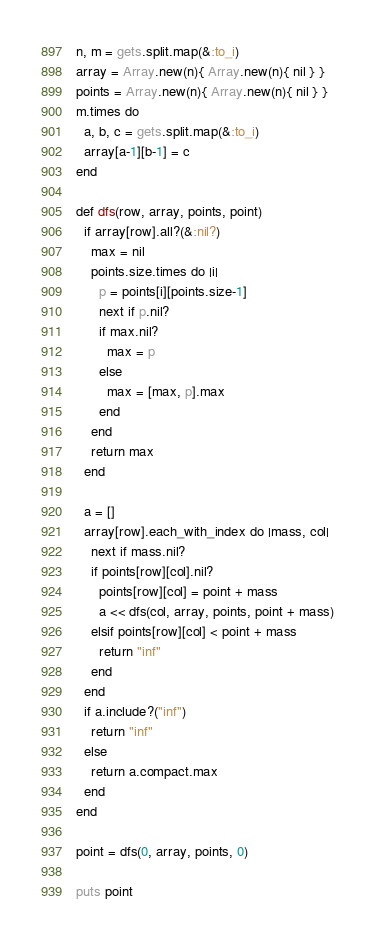Convert code to text. <code><loc_0><loc_0><loc_500><loc_500><_Ruby_>n, m = gets.split.map(&:to_i)
array = Array.new(n){ Array.new(n){ nil } }
points = Array.new(n){ Array.new(n){ nil } }
m.times do
  a, b, c = gets.split.map(&:to_i)
  array[a-1][b-1] = c
end

def dfs(row, array, points, point)
  if array[row].all?(&:nil?)
    max = nil
    points.size.times do |i|
      p = points[i][points.size-1]
      next if p.nil?
      if max.nil?
        max = p
      else
        max = [max, p].max
      end
    end
    return max
  end

  a = []
  array[row].each_with_index do |mass, col|
    next if mass.nil?
    if points[row][col].nil?
      points[row][col] = point + mass
      a << dfs(col, array, points, point + mass)
    elsif points[row][col] < point + mass
      return "inf"
    end
  end
  if a.include?("inf")
    return "inf"
  else
    return a.compact.max
  end
end

point = dfs(0, array, points, 0)

puts point
</code> 